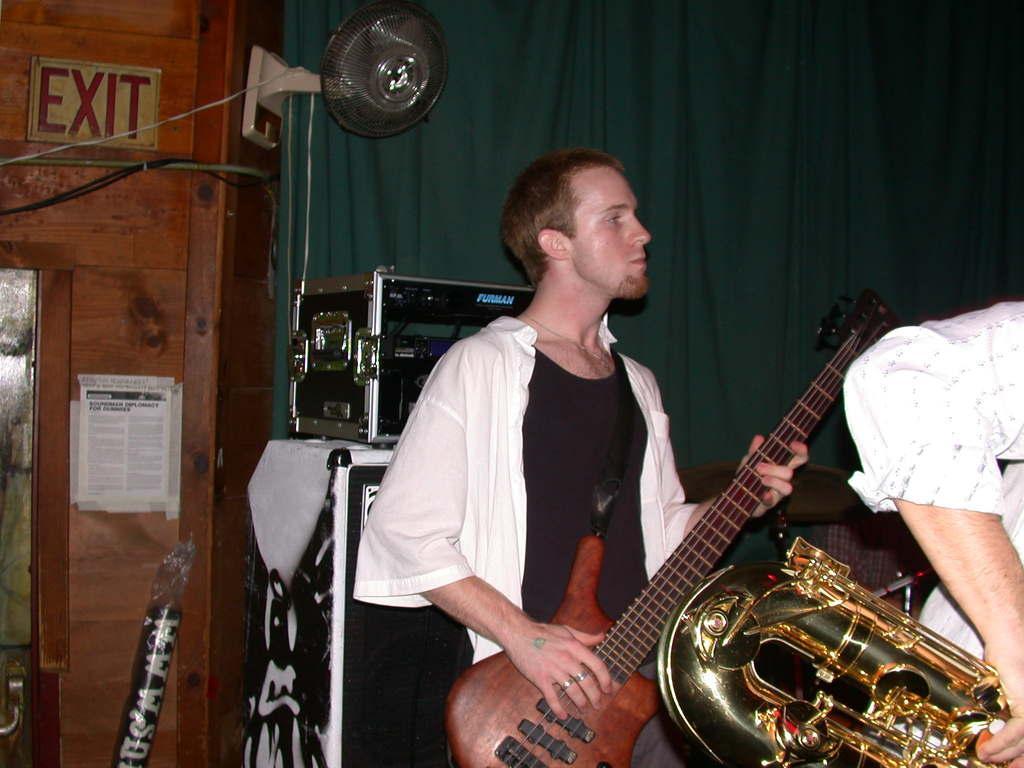Could you give a brief overview of what you see in this image? This picture seems to be clicked inside the room. In the foreground we can see the two people standing and seems to be playing the musical instruments. In the background we can see the curtain, wall mounted table fan, speaker and some other items and we can see a person like thing. 